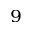<formula> <loc_0><loc_0><loc_500><loc_500>^ { 9 }</formula> 